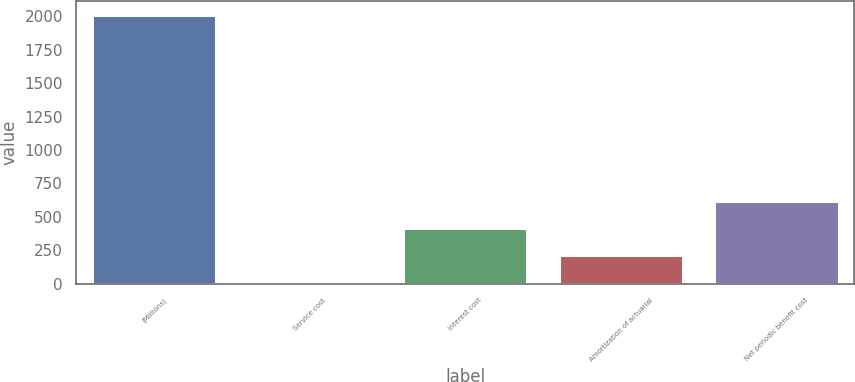Convert chart to OTSL. <chart><loc_0><loc_0><loc_500><loc_500><bar_chart><fcel>(Millions)<fcel>Service cost<fcel>Interest cost<fcel>Amortization of actuarial<fcel>Net periodic benefit cost<nl><fcel>2010<fcel>19<fcel>417.2<fcel>218.1<fcel>616.3<nl></chart> 